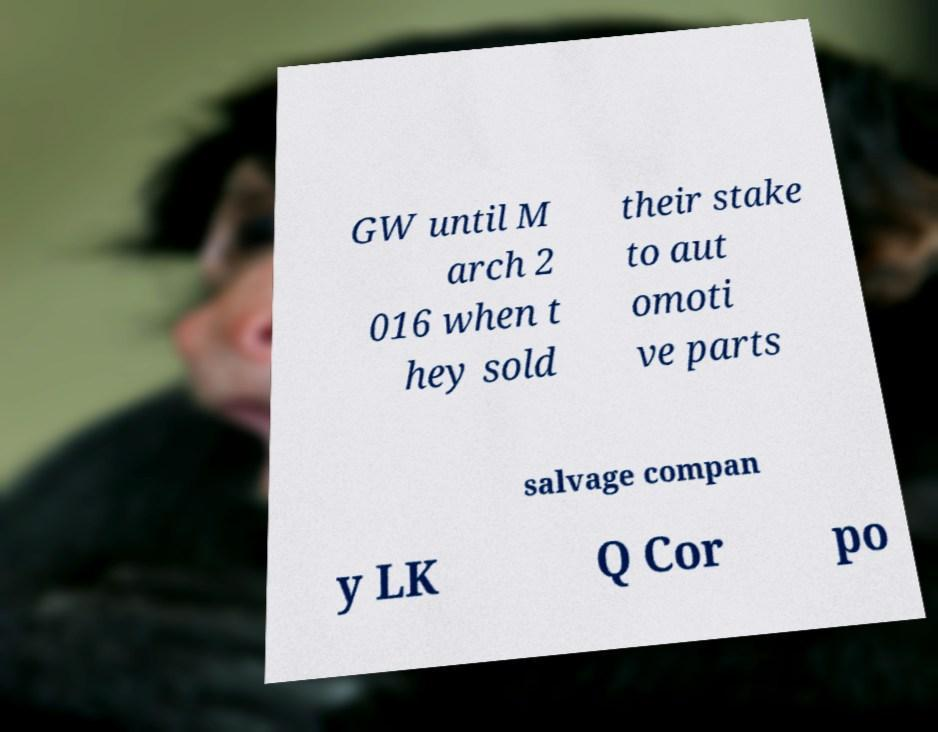What messages or text are displayed in this image? I need them in a readable, typed format. GW until M arch 2 016 when t hey sold their stake to aut omoti ve parts salvage compan y LK Q Cor po 